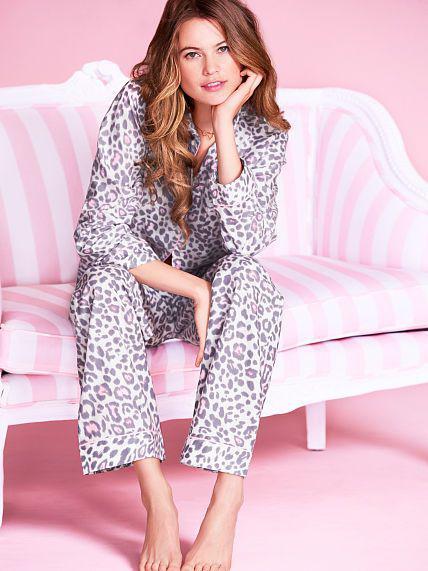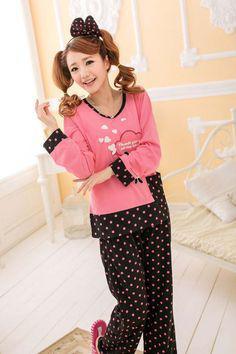The first image is the image on the left, the second image is the image on the right. Considering the images on both sides, is "At least one image in the pair shows a woman in pyjamas holding a lot of slippers." valid? Answer yes or no. No. The first image is the image on the left, the second image is the image on the right. Given the left and right images, does the statement "A woman is holding an armload of slippers in at least one of the images." hold true? Answer yes or no. No. 